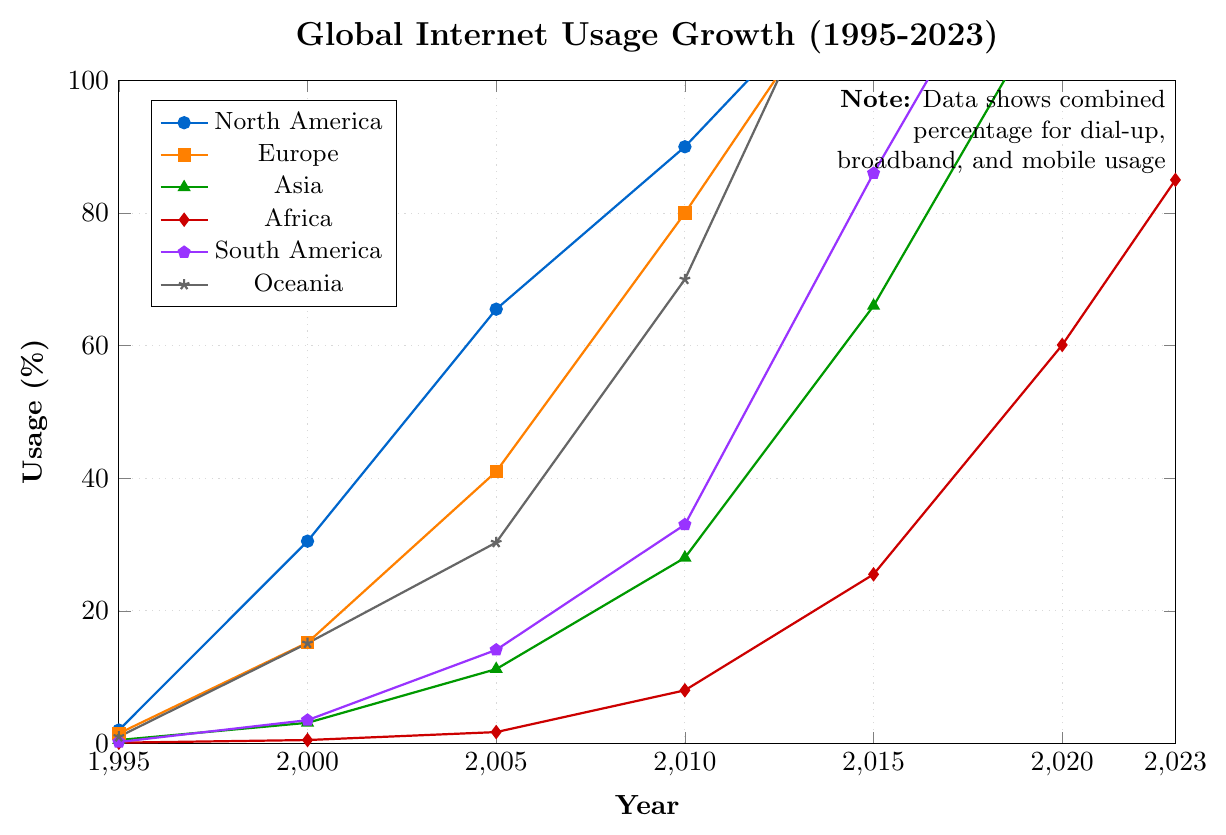What is the percentage of broadband usage in North America in 2023? Look at the line corresponding to broadband usage in North America (colored in blue) and find its value in 2023.
Answer: 90.0 What is the overall trend in mobile internet usage in Africa from 1995 to 2023? Follow the line corresponding to mobile usage in Africa (colored in red) from 1995 to 2023. Note the gradual increase over the years.
Answer: Increasing Which region has the highest combined percentage of internet usage in 2023? Compare the end points (2023) of all lines representing different regions. North America's line is the highest at approximately 185.1%.
Answer: North America By how much did broadband usage in Europe increase from 2000 to 2020? Locate the values for broadband usage in Europe in 2000 (0.2%) and in 2020 (80%). Subtract the former from the latter.
Answer: 79.8 Which region had the smallest percentage of dial-up usage in 2020? Compare the values of dial-up usage in 2020 across all regions and identify the smallest one, which is Asia at 0.1%.
Answer: Asia How does the increase in mobile usage in North America from 2015 to 2023 compare to the increase in mobile usage in Europe for the same period? Calculate the increase in mobile usage for North America (95.0% - 40.0% = 55.0%) and for Europe (90.0% - 50.0% = 40.0%). Compare these increases.
Answer: North America increased by 55.0% and Europe by 40.0% What is the average broadband usage in Oceania from 2015 to 2023? Identify the broadband usage values in Oceania for 2015 (70.0%), 2020 (80.0%), and 2023 (85.0%). Calculate the average: (70.0 + 80.0 + 85.0) / 3 = 78.3%.
Answer: 78.3 Did dial-up usage drop to zero in any region by 2023? Check the values for dial-up usage in 2023 across all regions. Yes, in Asia and Africa it dropped to 0.
Answer: Yes, in Asia and Africa Which region saw the largest increase in combined internet usage from 1995 to 2023? Calculate the combined usage in 2023 and 1995 for all regions. Determine the difference: North America (185.1-2.0=183.1%), Europe (175.1-1.5=173.6%), Asia (140.0-0.5=139.5%), Africa (85.0-0.1=84.9%), South America (155.1-0.2=154.9%), Oceania (180.0-1.0=179.0%). North America saw the largest increase.
Answer: North America has the largest increase of 183.1% 